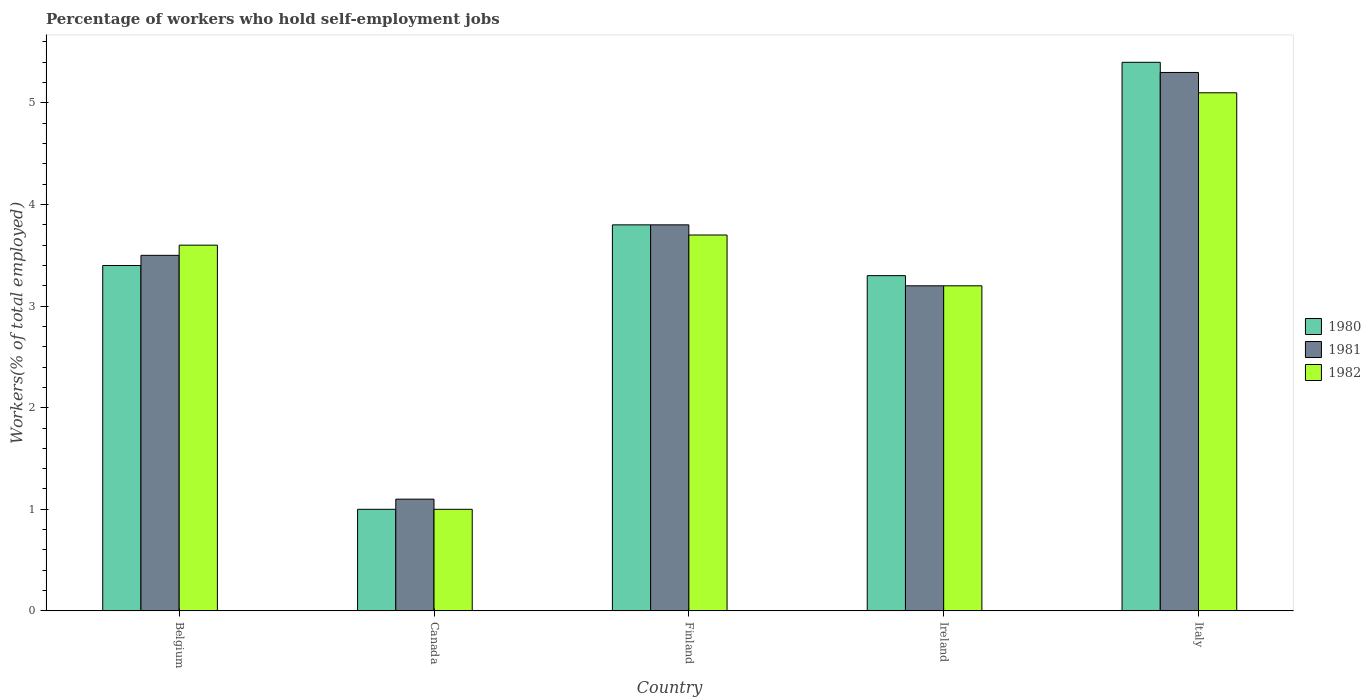How many groups of bars are there?
Your answer should be very brief. 5. Are the number of bars per tick equal to the number of legend labels?
Provide a short and direct response. Yes. Are the number of bars on each tick of the X-axis equal?
Give a very brief answer. Yes. How many bars are there on the 2nd tick from the left?
Provide a short and direct response. 3. How many bars are there on the 1st tick from the right?
Offer a terse response. 3. What is the label of the 1st group of bars from the left?
Offer a terse response. Belgium. In how many cases, is the number of bars for a given country not equal to the number of legend labels?
Keep it short and to the point. 0. What is the percentage of self-employed workers in 1981 in Ireland?
Your response must be concise. 3.2. Across all countries, what is the maximum percentage of self-employed workers in 1981?
Keep it short and to the point. 5.3. In which country was the percentage of self-employed workers in 1981 minimum?
Your answer should be very brief. Canada. What is the total percentage of self-employed workers in 1981 in the graph?
Provide a short and direct response. 16.9. What is the difference between the percentage of self-employed workers in 1980 in Belgium and that in Ireland?
Your answer should be very brief. 0.1. What is the difference between the percentage of self-employed workers in 1982 in Canada and the percentage of self-employed workers in 1980 in Finland?
Your response must be concise. -2.8. What is the average percentage of self-employed workers in 1980 per country?
Make the answer very short. 3.38. What is the difference between the percentage of self-employed workers of/in 1982 and percentage of self-employed workers of/in 1980 in Italy?
Provide a succinct answer. -0.3. What is the ratio of the percentage of self-employed workers in 1980 in Ireland to that in Italy?
Your response must be concise. 0.61. What is the difference between the highest and the second highest percentage of self-employed workers in 1981?
Your answer should be compact. -0.3. What is the difference between the highest and the lowest percentage of self-employed workers in 1980?
Offer a terse response. 4.4. What does the 1st bar from the left in Belgium represents?
Keep it short and to the point. 1980. Is it the case that in every country, the sum of the percentage of self-employed workers in 1980 and percentage of self-employed workers in 1982 is greater than the percentage of self-employed workers in 1981?
Ensure brevity in your answer.  Yes. Are all the bars in the graph horizontal?
Make the answer very short. No. Are the values on the major ticks of Y-axis written in scientific E-notation?
Offer a terse response. No. Does the graph contain any zero values?
Keep it short and to the point. No. Does the graph contain grids?
Provide a succinct answer. No. How many legend labels are there?
Your answer should be compact. 3. How are the legend labels stacked?
Make the answer very short. Vertical. What is the title of the graph?
Give a very brief answer. Percentage of workers who hold self-employment jobs. Does "1978" appear as one of the legend labels in the graph?
Offer a terse response. No. What is the label or title of the X-axis?
Ensure brevity in your answer.  Country. What is the label or title of the Y-axis?
Provide a short and direct response. Workers(% of total employed). What is the Workers(% of total employed) in 1980 in Belgium?
Ensure brevity in your answer.  3.4. What is the Workers(% of total employed) in 1981 in Belgium?
Provide a succinct answer. 3.5. What is the Workers(% of total employed) in 1982 in Belgium?
Your answer should be compact. 3.6. What is the Workers(% of total employed) in 1981 in Canada?
Make the answer very short. 1.1. What is the Workers(% of total employed) in 1980 in Finland?
Keep it short and to the point. 3.8. What is the Workers(% of total employed) of 1981 in Finland?
Ensure brevity in your answer.  3.8. What is the Workers(% of total employed) in 1982 in Finland?
Provide a short and direct response. 3.7. What is the Workers(% of total employed) of 1980 in Ireland?
Provide a short and direct response. 3.3. What is the Workers(% of total employed) of 1981 in Ireland?
Give a very brief answer. 3.2. What is the Workers(% of total employed) of 1982 in Ireland?
Your answer should be very brief. 3.2. What is the Workers(% of total employed) of 1980 in Italy?
Provide a succinct answer. 5.4. What is the Workers(% of total employed) in 1981 in Italy?
Your response must be concise. 5.3. What is the Workers(% of total employed) of 1982 in Italy?
Provide a succinct answer. 5.1. Across all countries, what is the maximum Workers(% of total employed) in 1980?
Offer a very short reply. 5.4. Across all countries, what is the maximum Workers(% of total employed) of 1981?
Offer a terse response. 5.3. Across all countries, what is the maximum Workers(% of total employed) in 1982?
Keep it short and to the point. 5.1. Across all countries, what is the minimum Workers(% of total employed) of 1980?
Ensure brevity in your answer.  1. Across all countries, what is the minimum Workers(% of total employed) of 1981?
Keep it short and to the point. 1.1. Across all countries, what is the minimum Workers(% of total employed) in 1982?
Your response must be concise. 1. What is the total Workers(% of total employed) in 1980 in the graph?
Provide a short and direct response. 16.9. What is the total Workers(% of total employed) in 1982 in the graph?
Offer a very short reply. 16.6. What is the difference between the Workers(% of total employed) of 1980 in Belgium and that in Canada?
Keep it short and to the point. 2.4. What is the difference between the Workers(% of total employed) in 1980 in Belgium and that in Finland?
Provide a short and direct response. -0.4. What is the difference between the Workers(% of total employed) of 1981 in Belgium and that in Finland?
Ensure brevity in your answer.  -0.3. What is the difference between the Workers(% of total employed) in 1982 in Belgium and that in Finland?
Ensure brevity in your answer.  -0.1. What is the difference between the Workers(% of total employed) in 1980 in Belgium and that in Ireland?
Provide a succinct answer. 0.1. What is the difference between the Workers(% of total employed) in 1981 in Belgium and that in Italy?
Provide a succinct answer. -1.8. What is the difference between the Workers(% of total employed) in 1982 in Belgium and that in Italy?
Provide a short and direct response. -1.5. What is the difference between the Workers(% of total employed) in 1980 in Canada and that in Italy?
Your answer should be very brief. -4.4. What is the difference between the Workers(% of total employed) of 1981 in Canada and that in Italy?
Ensure brevity in your answer.  -4.2. What is the difference between the Workers(% of total employed) in 1982 in Canada and that in Italy?
Offer a terse response. -4.1. What is the difference between the Workers(% of total employed) of 1981 in Finland and that in Ireland?
Keep it short and to the point. 0.6. What is the difference between the Workers(% of total employed) of 1980 in Finland and that in Italy?
Your answer should be compact. -1.6. What is the difference between the Workers(% of total employed) of 1982 in Finland and that in Italy?
Your answer should be compact. -1.4. What is the difference between the Workers(% of total employed) in 1980 in Ireland and that in Italy?
Provide a short and direct response. -2.1. What is the difference between the Workers(% of total employed) of 1981 in Ireland and that in Italy?
Ensure brevity in your answer.  -2.1. What is the difference between the Workers(% of total employed) of 1980 in Belgium and the Workers(% of total employed) of 1981 in Canada?
Your answer should be very brief. 2.3. What is the difference between the Workers(% of total employed) in 1980 in Belgium and the Workers(% of total employed) in 1982 in Canada?
Provide a short and direct response. 2.4. What is the difference between the Workers(% of total employed) of 1981 in Belgium and the Workers(% of total employed) of 1982 in Canada?
Your answer should be very brief. 2.5. What is the difference between the Workers(% of total employed) of 1980 in Belgium and the Workers(% of total employed) of 1981 in Finland?
Provide a succinct answer. -0.4. What is the difference between the Workers(% of total employed) in 1980 in Belgium and the Workers(% of total employed) in 1982 in Finland?
Your answer should be very brief. -0.3. What is the difference between the Workers(% of total employed) of 1981 in Belgium and the Workers(% of total employed) of 1982 in Finland?
Make the answer very short. -0.2. What is the difference between the Workers(% of total employed) in 1980 in Belgium and the Workers(% of total employed) in 1982 in Ireland?
Give a very brief answer. 0.2. What is the difference between the Workers(% of total employed) of 1981 in Belgium and the Workers(% of total employed) of 1982 in Italy?
Offer a very short reply. -1.6. What is the difference between the Workers(% of total employed) of 1980 in Canada and the Workers(% of total employed) of 1981 in Finland?
Keep it short and to the point. -2.8. What is the difference between the Workers(% of total employed) of 1980 in Canada and the Workers(% of total employed) of 1982 in Finland?
Keep it short and to the point. -2.7. What is the difference between the Workers(% of total employed) of 1981 in Canada and the Workers(% of total employed) of 1982 in Finland?
Your answer should be compact. -2.6. What is the difference between the Workers(% of total employed) in 1980 in Canada and the Workers(% of total employed) in 1982 in Ireland?
Provide a succinct answer. -2.2. What is the difference between the Workers(% of total employed) in 1981 in Canada and the Workers(% of total employed) in 1982 in Ireland?
Offer a terse response. -2.1. What is the difference between the Workers(% of total employed) of 1980 in Canada and the Workers(% of total employed) of 1981 in Italy?
Give a very brief answer. -4.3. What is the difference between the Workers(% of total employed) of 1980 in Canada and the Workers(% of total employed) of 1982 in Italy?
Keep it short and to the point. -4.1. What is the difference between the Workers(% of total employed) of 1981 in Canada and the Workers(% of total employed) of 1982 in Italy?
Your answer should be compact. -4. What is the difference between the Workers(% of total employed) in 1980 in Finland and the Workers(% of total employed) in 1981 in Ireland?
Offer a very short reply. 0.6. What is the difference between the Workers(% of total employed) in 1981 in Finland and the Workers(% of total employed) in 1982 in Ireland?
Keep it short and to the point. 0.6. What is the difference between the Workers(% of total employed) in 1980 in Finland and the Workers(% of total employed) in 1981 in Italy?
Your answer should be very brief. -1.5. What is the difference between the Workers(% of total employed) in 1980 in Finland and the Workers(% of total employed) in 1982 in Italy?
Provide a short and direct response. -1.3. What is the difference between the Workers(% of total employed) in 1981 in Finland and the Workers(% of total employed) in 1982 in Italy?
Your response must be concise. -1.3. What is the difference between the Workers(% of total employed) in 1981 in Ireland and the Workers(% of total employed) in 1982 in Italy?
Offer a terse response. -1.9. What is the average Workers(% of total employed) in 1980 per country?
Your answer should be very brief. 3.38. What is the average Workers(% of total employed) in 1981 per country?
Your answer should be very brief. 3.38. What is the average Workers(% of total employed) of 1982 per country?
Offer a terse response. 3.32. What is the difference between the Workers(% of total employed) of 1980 and Workers(% of total employed) of 1981 in Belgium?
Your answer should be very brief. -0.1. What is the difference between the Workers(% of total employed) of 1980 and Workers(% of total employed) of 1982 in Belgium?
Provide a short and direct response. -0.2. What is the difference between the Workers(% of total employed) in 1981 and Workers(% of total employed) in 1982 in Belgium?
Keep it short and to the point. -0.1. What is the difference between the Workers(% of total employed) in 1980 and Workers(% of total employed) in 1981 in Canada?
Offer a very short reply. -0.1. What is the difference between the Workers(% of total employed) in 1980 and Workers(% of total employed) in 1982 in Ireland?
Your answer should be very brief. 0.1. What is the ratio of the Workers(% of total employed) of 1980 in Belgium to that in Canada?
Keep it short and to the point. 3.4. What is the ratio of the Workers(% of total employed) of 1981 in Belgium to that in Canada?
Provide a short and direct response. 3.18. What is the ratio of the Workers(% of total employed) of 1980 in Belgium to that in Finland?
Make the answer very short. 0.89. What is the ratio of the Workers(% of total employed) in 1981 in Belgium to that in Finland?
Ensure brevity in your answer.  0.92. What is the ratio of the Workers(% of total employed) in 1982 in Belgium to that in Finland?
Offer a terse response. 0.97. What is the ratio of the Workers(% of total employed) of 1980 in Belgium to that in Ireland?
Provide a short and direct response. 1.03. What is the ratio of the Workers(% of total employed) in 1981 in Belgium to that in Ireland?
Ensure brevity in your answer.  1.09. What is the ratio of the Workers(% of total employed) of 1982 in Belgium to that in Ireland?
Your answer should be compact. 1.12. What is the ratio of the Workers(% of total employed) in 1980 in Belgium to that in Italy?
Offer a very short reply. 0.63. What is the ratio of the Workers(% of total employed) in 1981 in Belgium to that in Italy?
Offer a very short reply. 0.66. What is the ratio of the Workers(% of total employed) in 1982 in Belgium to that in Italy?
Offer a very short reply. 0.71. What is the ratio of the Workers(% of total employed) of 1980 in Canada to that in Finland?
Your response must be concise. 0.26. What is the ratio of the Workers(% of total employed) in 1981 in Canada to that in Finland?
Offer a very short reply. 0.29. What is the ratio of the Workers(% of total employed) in 1982 in Canada to that in Finland?
Your response must be concise. 0.27. What is the ratio of the Workers(% of total employed) of 1980 in Canada to that in Ireland?
Keep it short and to the point. 0.3. What is the ratio of the Workers(% of total employed) in 1981 in Canada to that in Ireland?
Give a very brief answer. 0.34. What is the ratio of the Workers(% of total employed) in 1982 in Canada to that in Ireland?
Keep it short and to the point. 0.31. What is the ratio of the Workers(% of total employed) in 1980 in Canada to that in Italy?
Make the answer very short. 0.19. What is the ratio of the Workers(% of total employed) in 1981 in Canada to that in Italy?
Provide a succinct answer. 0.21. What is the ratio of the Workers(% of total employed) of 1982 in Canada to that in Italy?
Provide a short and direct response. 0.2. What is the ratio of the Workers(% of total employed) of 1980 in Finland to that in Ireland?
Make the answer very short. 1.15. What is the ratio of the Workers(% of total employed) of 1981 in Finland to that in Ireland?
Offer a terse response. 1.19. What is the ratio of the Workers(% of total employed) in 1982 in Finland to that in Ireland?
Offer a terse response. 1.16. What is the ratio of the Workers(% of total employed) in 1980 in Finland to that in Italy?
Give a very brief answer. 0.7. What is the ratio of the Workers(% of total employed) of 1981 in Finland to that in Italy?
Your response must be concise. 0.72. What is the ratio of the Workers(% of total employed) in 1982 in Finland to that in Italy?
Your response must be concise. 0.73. What is the ratio of the Workers(% of total employed) of 1980 in Ireland to that in Italy?
Make the answer very short. 0.61. What is the ratio of the Workers(% of total employed) of 1981 in Ireland to that in Italy?
Offer a terse response. 0.6. What is the ratio of the Workers(% of total employed) in 1982 in Ireland to that in Italy?
Your answer should be compact. 0.63. What is the difference between the highest and the second highest Workers(% of total employed) in 1980?
Offer a terse response. 1.6. What is the difference between the highest and the second highest Workers(% of total employed) in 1982?
Keep it short and to the point. 1.4. 